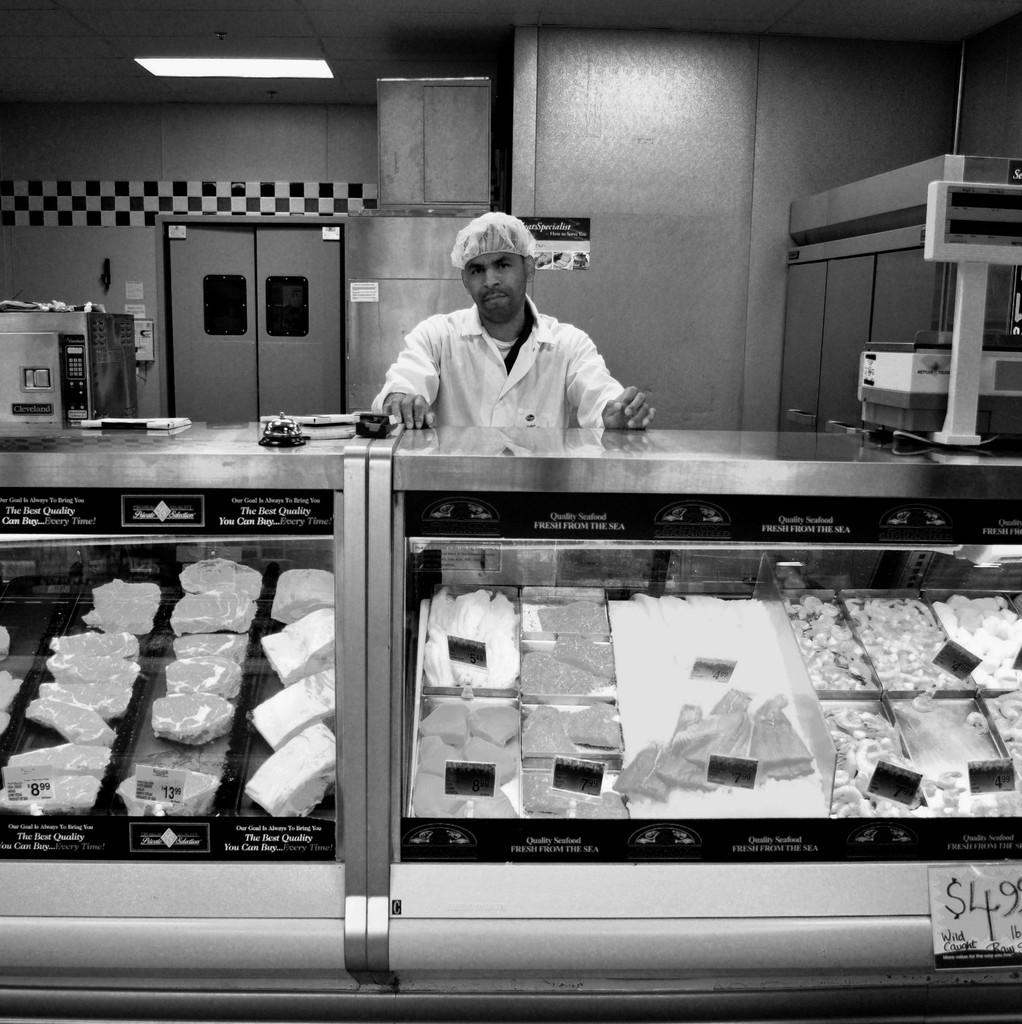<image>
Render a clear and concise summary of the photo. A man stands at the deli in front a label that reads "The Best Quality You Can Buy" 